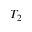Convert formula to latex. <formula><loc_0><loc_0><loc_500><loc_500>T _ { 2 }</formula> 